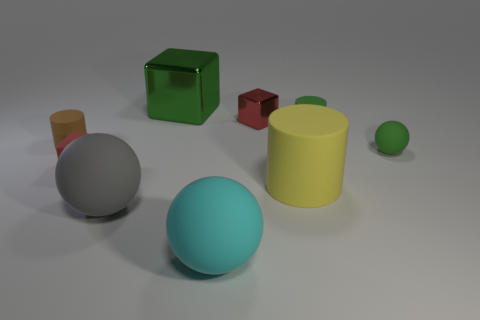There is a gray matte sphere; is it the same size as the cylinder left of the big green metal block?
Provide a succinct answer. No. There is a gray matte object that is the same shape as the large cyan thing; what size is it?
Keep it short and to the point. Large. Are there any other things that are made of the same material as the big yellow cylinder?
Your answer should be very brief. Yes. There is a cylinder behind the tiny brown rubber cylinder; is it the same size as the matte cylinder that is on the left side of the green metallic thing?
Make the answer very short. Yes. What number of tiny things are either cyan rubber things or gray metal objects?
Give a very brief answer. 0. What number of balls are right of the big cyan object and left of the tiny sphere?
Provide a succinct answer. 0. Are there the same number of big blocks and large purple metallic spheres?
Your answer should be very brief. No. Is the tiny green ball made of the same material as the green thing that is on the left side of the cyan matte ball?
Your answer should be very brief. No. What number of blue things are either small matte cylinders or balls?
Provide a succinct answer. 0. Are there any brown cylinders that have the same size as the gray rubber thing?
Provide a short and direct response. No. 